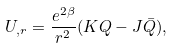<formula> <loc_0><loc_0><loc_500><loc_500>U _ { , r } = \frac { e ^ { 2 \beta } } { r ^ { 2 } } ( K Q - J \bar { Q } ) ,</formula> 